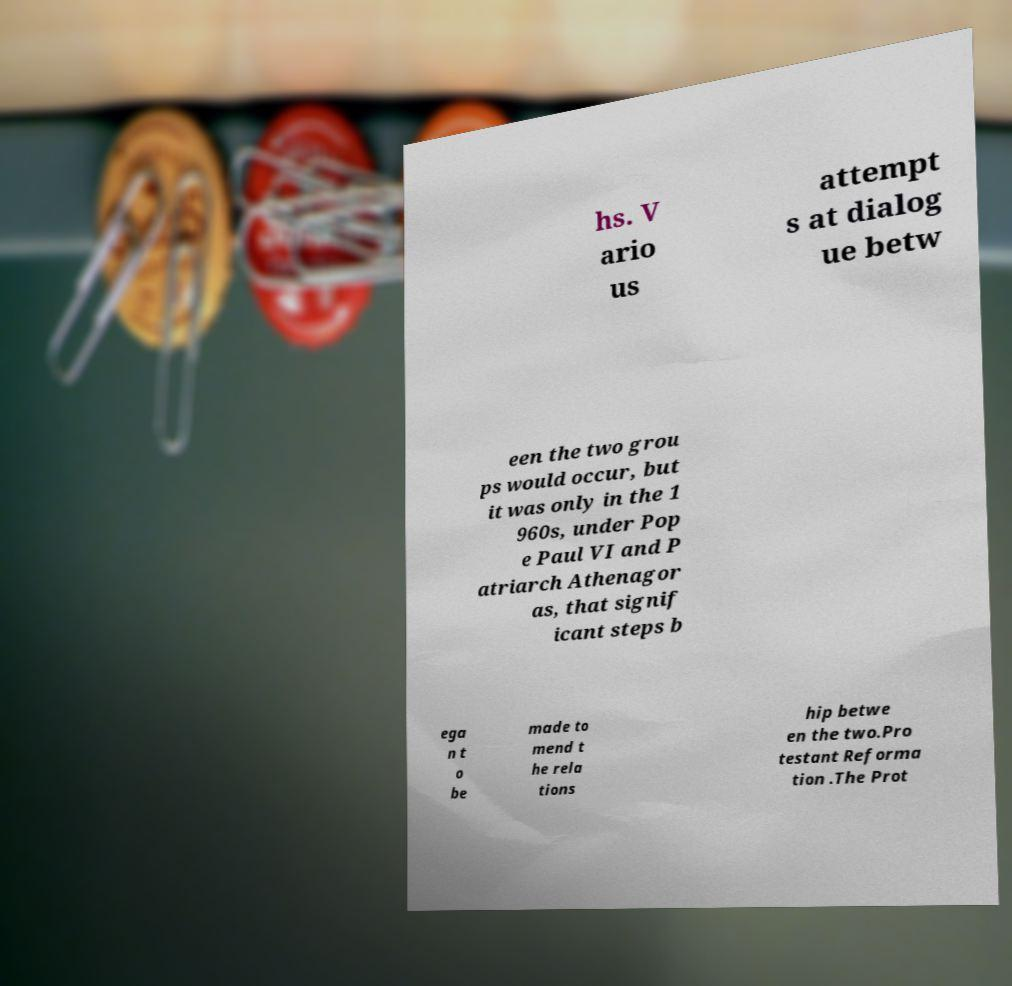What messages or text are displayed in this image? I need them in a readable, typed format. hs. V ario us attempt s at dialog ue betw een the two grou ps would occur, but it was only in the 1 960s, under Pop e Paul VI and P atriarch Athenagor as, that signif icant steps b ega n t o be made to mend t he rela tions hip betwe en the two.Pro testant Reforma tion .The Prot 